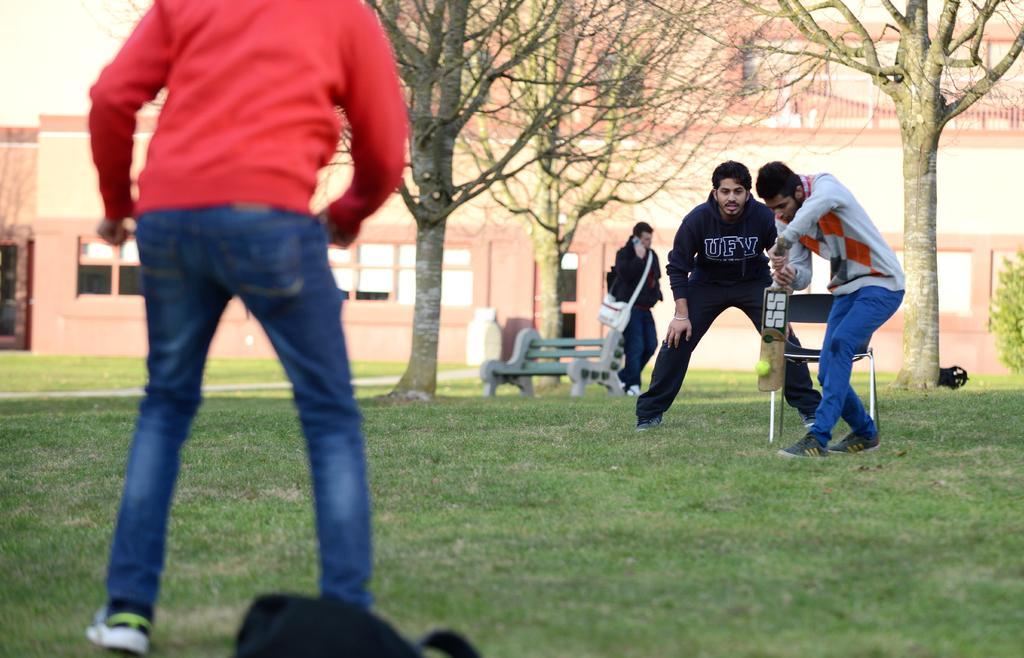In one or two sentences, can you explain what this image depicts? In the picture we can see a grass surface on it, we can see some people are playing a cricket and behind them, we can see one man is walking wearing a bag and talking on the mobile and beside him we can see a bench and trees and behind it we can see some buildings. 